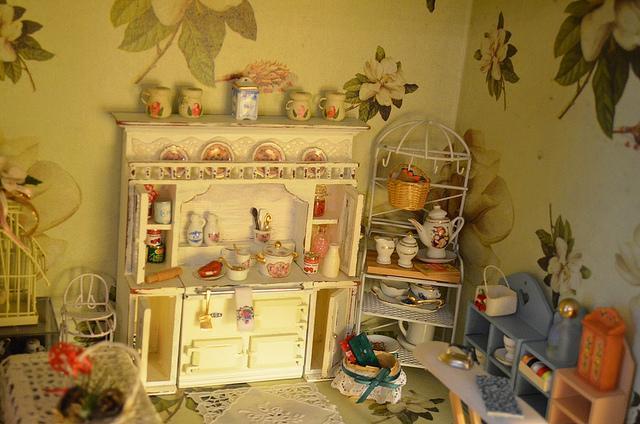How many people are in the picture?
Give a very brief answer. 0. 